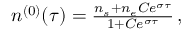<formula> <loc_0><loc_0><loc_500><loc_500>\begin{array} { r } { n ^ { ( 0 ) } ( \tau ) = \frac { n _ { s } + n _ { e } C e ^ { \sigma \tau } } { 1 + C e ^ { \sigma \tau } } \, , } \end{array}</formula> 